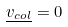<formula> <loc_0><loc_0><loc_500><loc_500>\underline { v _ { c o l } } = 0</formula> 